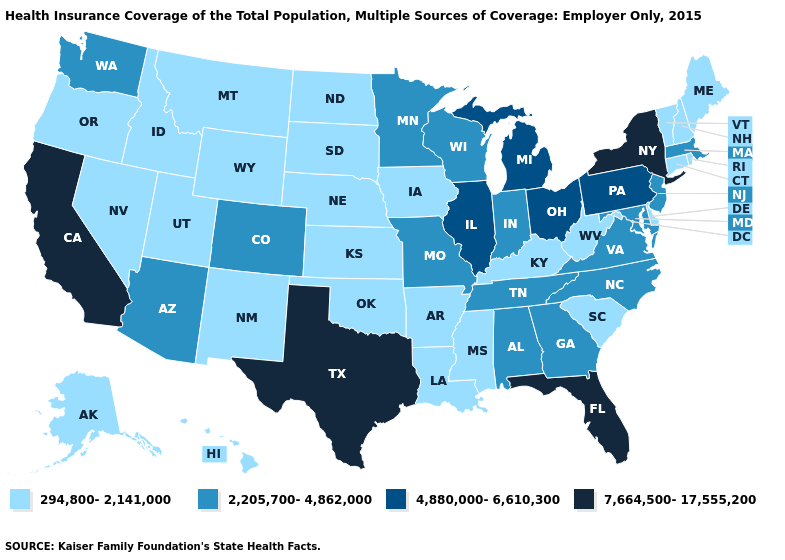Does the map have missing data?
Answer briefly. No. What is the lowest value in the USA?
Keep it brief. 294,800-2,141,000. Which states have the lowest value in the West?
Answer briefly. Alaska, Hawaii, Idaho, Montana, Nevada, New Mexico, Oregon, Utah, Wyoming. What is the value of California?
Quick response, please. 7,664,500-17,555,200. Does Florida have the lowest value in the USA?
Concise answer only. No. What is the value of Texas?
Short answer required. 7,664,500-17,555,200. Which states have the lowest value in the USA?
Concise answer only. Alaska, Arkansas, Connecticut, Delaware, Hawaii, Idaho, Iowa, Kansas, Kentucky, Louisiana, Maine, Mississippi, Montana, Nebraska, Nevada, New Hampshire, New Mexico, North Dakota, Oklahoma, Oregon, Rhode Island, South Carolina, South Dakota, Utah, Vermont, West Virginia, Wyoming. What is the value of New York?
Be succinct. 7,664,500-17,555,200. Does the map have missing data?
Concise answer only. No. What is the value of Pennsylvania?
Give a very brief answer. 4,880,000-6,610,300. Which states have the lowest value in the USA?
Concise answer only. Alaska, Arkansas, Connecticut, Delaware, Hawaii, Idaho, Iowa, Kansas, Kentucky, Louisiana, Maine, Mississippi, Montana, Nebraska, Nevada, New Hampshire, New Mexico, North Dakota, Oklahoma, Oregon, Rhode Island, South Carolina, South Dakota, Utah, Vermont, West Virginia, Wyoming. What is the value of Ohio?
Short answer required. 4,880,000-6,610,300. Does Tennessee have the lowest value in the USA?
Short answer required. No. Name the states that have a value in the range 4,880,000-6,610,300?
Keep it brief. Illinois, Michigan, Ohio, Pennsylvania. Does Alabama have the same value as North Carolina?
Write a very short answer. Yes. 